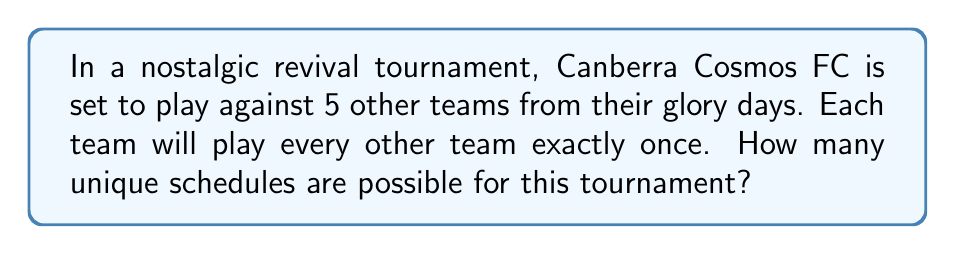Solve this math problem. Let's approach this step-by-step:

1) First, we need to calculate the total number of matches in the tournament:
   - There are 6 teams in total (Canberra Cosmos FC and 5 others)
   - Each team plays every other team once
   - The number of matches is given by the combination formula: $\binom{6}{2} = \frac{6!}{2!(6-2)!} = \frac{6 \cdot 5}{2} = 15$

2) Now, we need to determine how many ways we can arrange these 15 matches:
   - This is a permutation of 15 items
   - The number of permutations is given by 15!

3) However, the order of teams within each match doesn't matter:
   - For each of the 15 matches, there are 2! ways to arrange the teams
   - We need to divide our total by $(2!)^{15}$ to account for this

4) Therefore, the total number of unique schedules is:

   $$\frac{15!}{(2!)^{15}}$$

5) Calculating this:
   
   $$\frac{15!}{(2!)^{15}} = \frac{1,307,674,368,000}{32,768} = 39,916,800$$
Answer: 39,916,800 